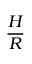Convert formula to latex. <formula><loc_0><loc_0><loc_500><loc_500>\frac { H } { R }</formula> 